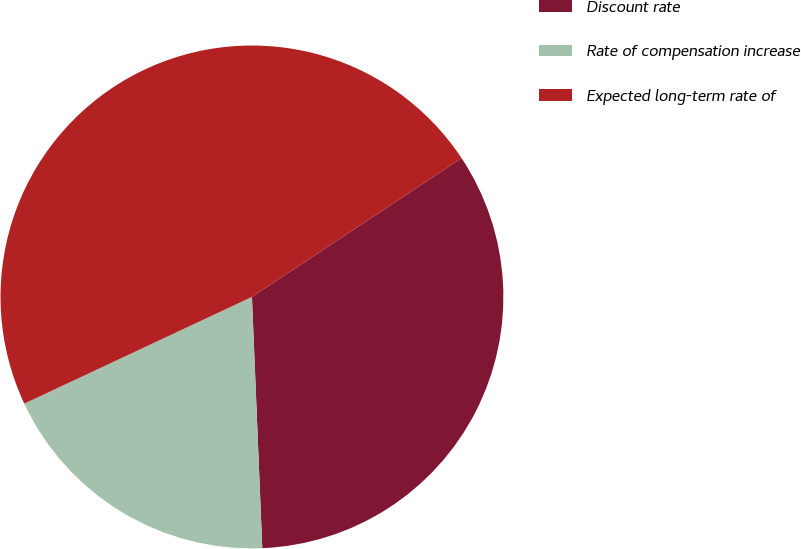Convert chart. <chart><loc_0><loc_0><loc_500><loc_500><pie_chart><fcel>Discount rate<fcel>Rate of compensation increase<fcel>Expected long-term rate of<nl><fcel>33.65%<fcel>18.68%<fcel>47.67%<nl></chart> 